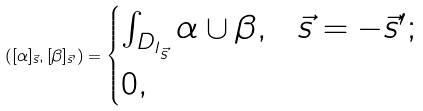Convert formula to latex. <formula><loc_0><loc_0><loc_500><loc_500>( [ \alpha ] _ { \vec { s } } , [ \beta ] _ { \vec { s } ^ { \prime } } ) = \begin{cases} \int _ { D _ { I _ { \vec { s } } } } \alpha \cup \beta , & \vec { s } = - \vec { s } ^ { \prime } ; \\ 0 , & \end{cases}</formula> 